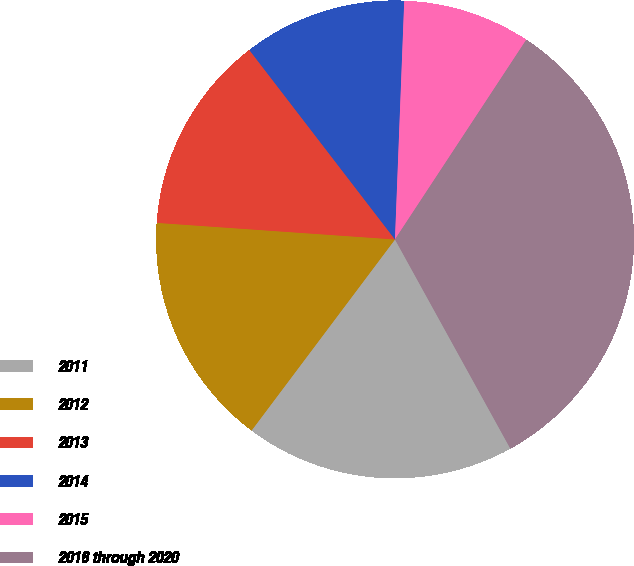<chart> <loc_0><loc_0><loc_500><loc_500><pie_chart><fcel>2011<fcel>2012<fcel>2013<fcel>2014<fcel>2015<fcel>2016 through 2020<nl><fcel>18.27%<fcel>15.86%<fcel>13.46%<fcel>11.05%<fcel>8.64%<fcel>32.72%<nl></chart> 